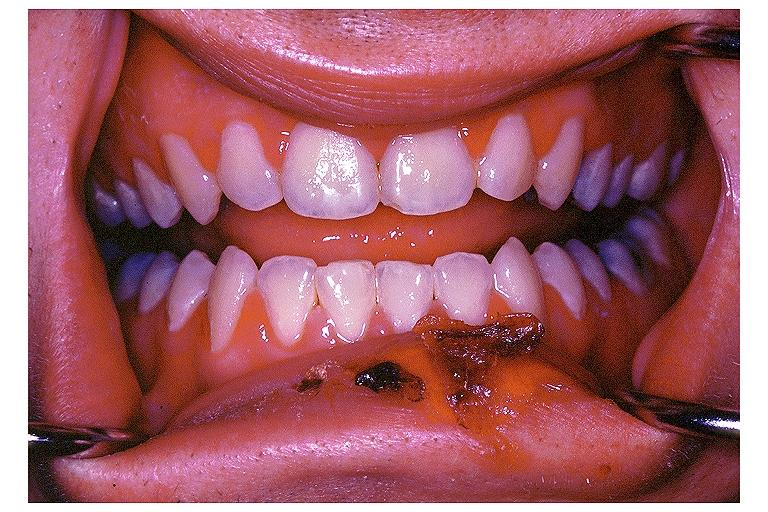does this image show primary herpetic gingivo-stomatitis?
Answer the question using a single word or phrase. Yes 